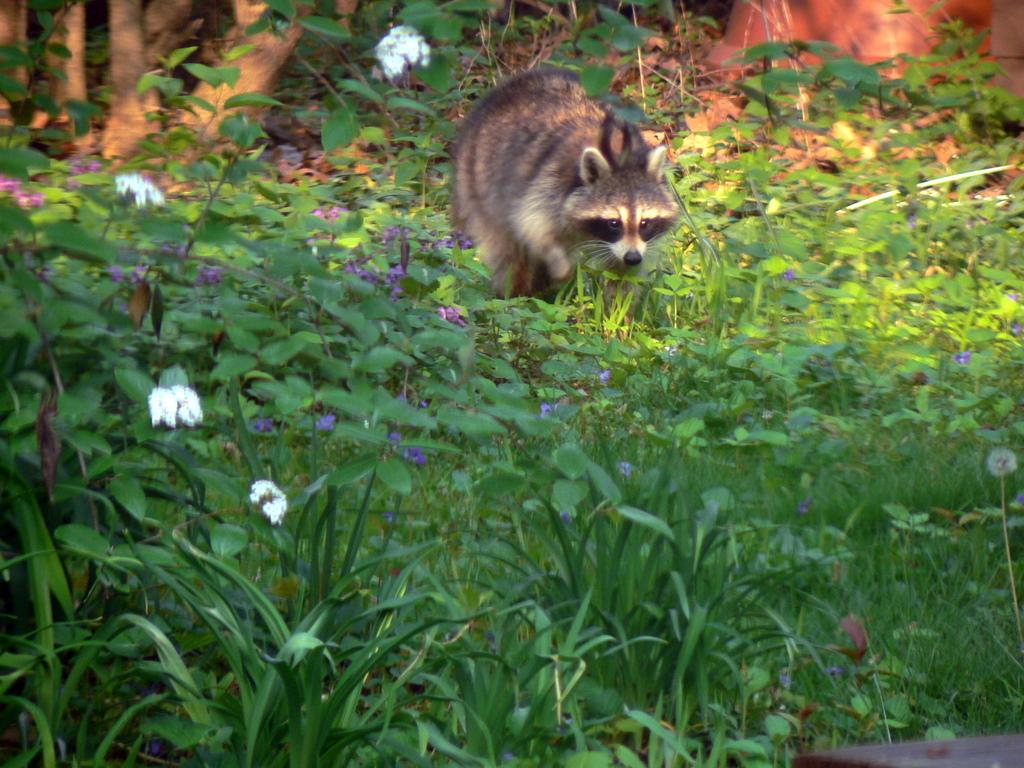What type of plants can be seen in the image? There are flowering plants in the image. What is the animal doing in the image? The animal is on the grass in the image. What part of a tree is visible in the image? Tree trunks are visible in the image. Where might this image have been taken? The image may have been taken in a forest, given the presence of flowering plants, tree trunks, and grass. What type of fowl can be seen in the image? There is no fowl present in the image. What is the porter carrying in the image? There is no porter present in the image. 